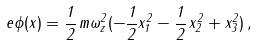<formula> <loc_0><loc_0><loc_500><loc_500>e \phi ( x ) = \frac { 1 } { 2 } \, m \omega _ { z } ^ { 2 } ( - \frac { 1 } { 2 } x _ { 1 } ^ { 2 } - \frac { 1 } { 2 } \, x _ { 2 } ^ { 2 } + x _ { 3 } ^ { 2 } ) \, ,</formula> 